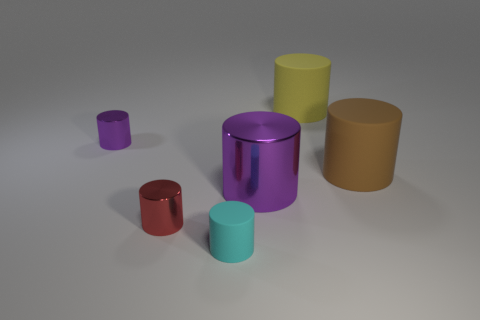What size is the other shiny object that is the same color as the big shiny thing?
Your answer should be compact. Small. Is there a large brown thing that has the same material as the tiny red cylinder?
Give a very brief answer. No. There is a tiny object that is behind the small red shiny cylinder; what material is it?
Offer a terse response. Metal. Do the big thing that is left of the yellow cylinder and the small thing behind the big purple metallic object have the same color?
Provide a succinct answer. Yes. There is a rubber object that is the same size as the brown rubber cylinder; what color is it?
Provide a succinct answer. Yellow. What number of other objects are the same shape as the tiny purple shiny thing?
Make the answer very short. 5. There is a purple metallic object behind the large metallic cylinder; what is its size?
Ensure brevity in your answer.  Small. There is a rubber cylinder that is left of the large yellow cylinder; how many yellow matte cylinders are in front of it?
Offer a very short reply. 0. Does the purple metal thing behind the large purple metal cylinder have the same shape as the large brown rubber thing?
Ensure brevity in your answer.  Yes. How many objects are both left of the cyan rubber object and on the right side of the big yellow cylinder?
Offer a very short reply. 0. 